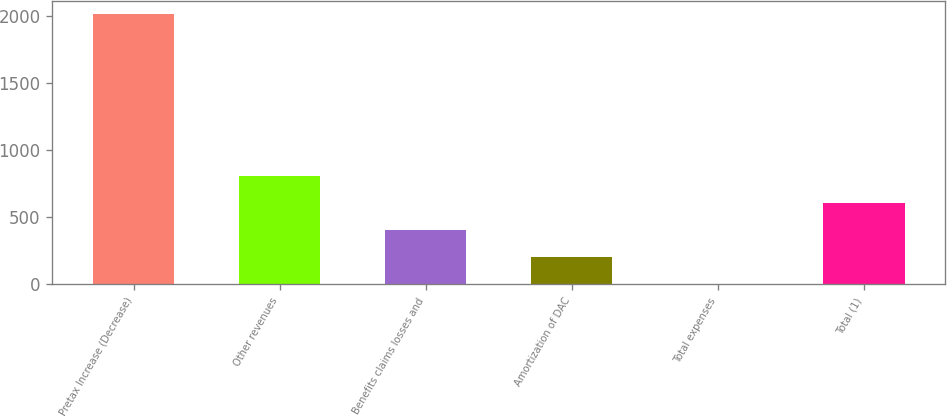<chart> <loc_0><loc_0><loc_500><loc_500><bar_chart><fcel>Pretax Increase (Decrease)<fcel>Other revenues<fcel>Benefits claims losses and<fcel>Amortization of DAC<fcel>Total expenses<fcel>Total (1)<nl><fcel>2012<fcel>806.6<fcel>404.8<fcel>203.9<fcel>3<fcel>605.7<nl></chart> 